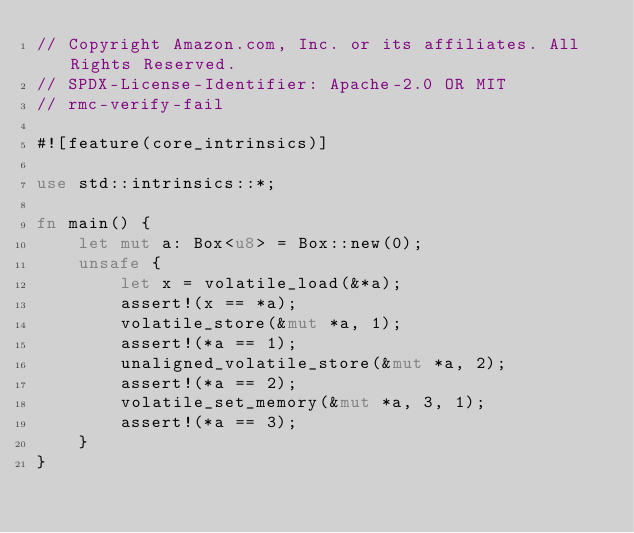Convert code to text. <code><loc_0><loc_0><loc_500><loc_500><_Rust_>// Copyright Amazon.com, Inc. or its affiliates. All Rights Reserved.
// SPDX-License-Identifier: Apache-2.0 OR MIT
// rmc-verify-fail

#![feature(core_intrinsics)]

use std::intrinsics::*;

fn main() {
    let mut a: Box<u8> = Box::new(0);
    unsafe {
        let x = volatile_load(&*a);
        assert!(x == *a);
        volatile_store(&mut *a, 1);
        assert!(*a == 1);
        unaligned_volatile_store(&mut *a, 2);
        assert!(*a == 2);
        volatile_set_memory(&mut *a, 3, 1);
        assert!(*a == 3);
    }
}
</code> 